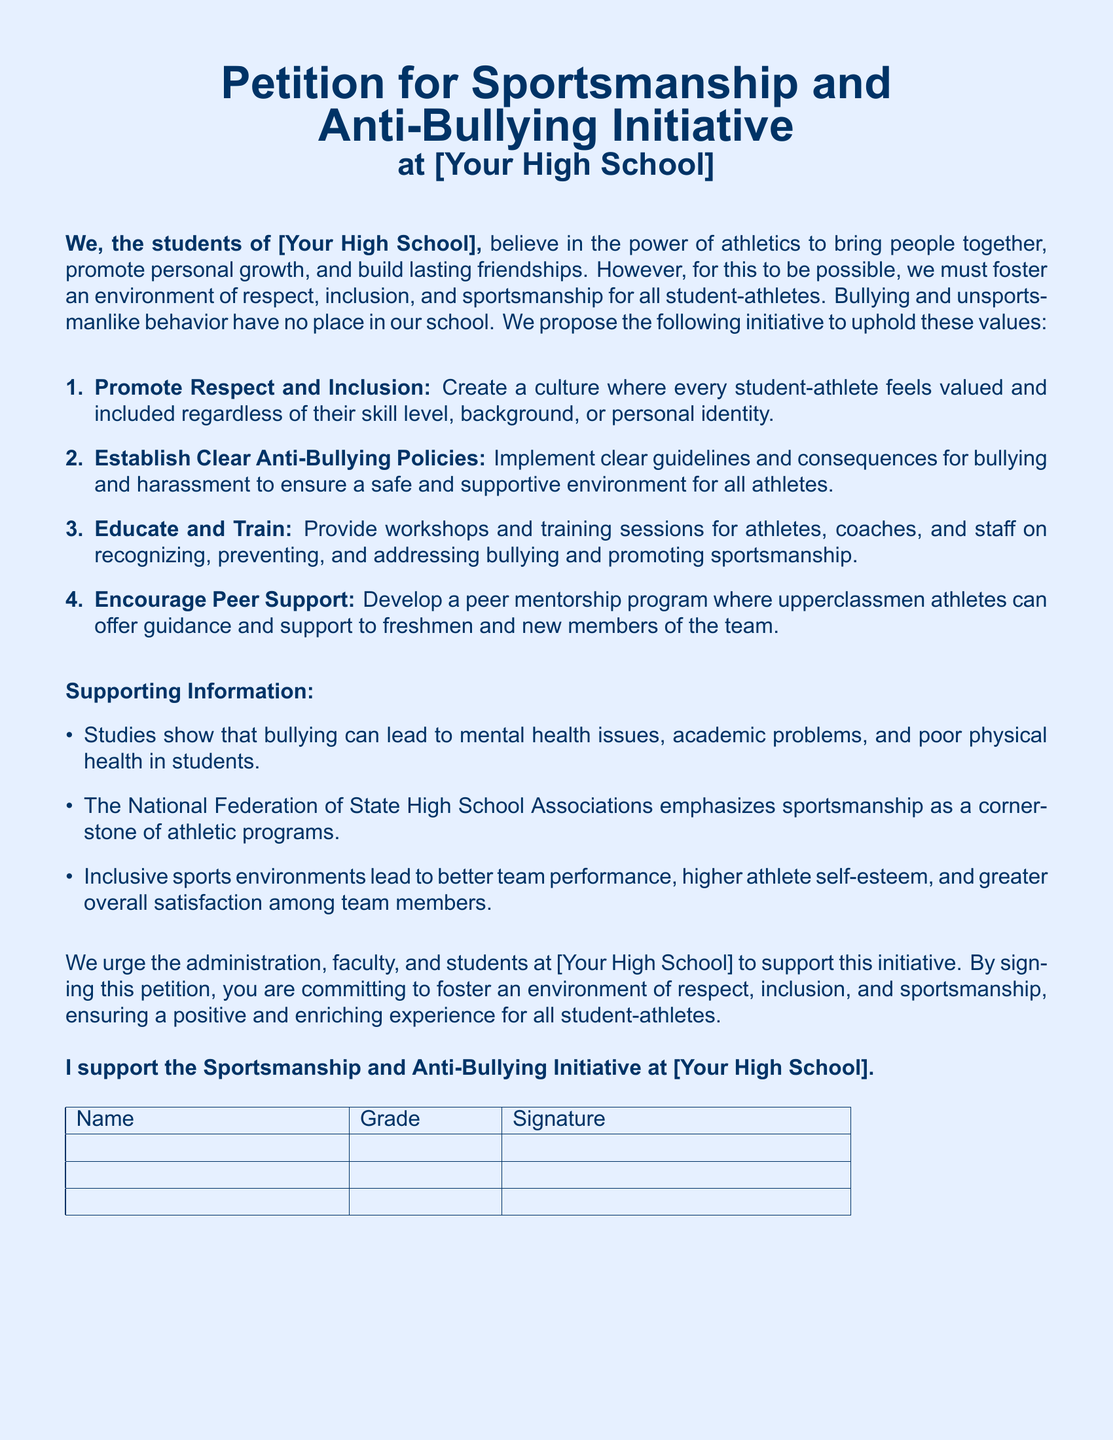What is the title of the petition? The title of the petition is stated at the beginning of the document, which is "Petition for Sportsmanship and Anti-Bullying Initiative."
Answer: Petition for Sportsmanship and Anti-Bullying Initiative What school is the petition addressing? The petition addresses "[Your High School]," which is a placeholder for the actual school name.
Answer: [Your High School] How many points are proposed in the initiative? The document lists four specific points in the initiative, indicating the proposed actions.
Answer: 4 What type of program is suggested for upperclassmen athletes? The initiative includes a suggestion for a peer mentorship program to support newcomers in athletics.
Answer: Peer mentorship program What does the National Federation of State High School Associations emphasize? It emphasizes that sportsmanship is a cornerstone of athletic programs, indicating its importance in sports.
Answer: Sportsmanship What is the main goal of the initiative? The main goal is to foster an environment of respect, inclusion, and sportsmanship among student-athletes.
Answer: Respect, inclusion, and sportsmanship What does the petition ask from the administration and faculty? The petition urges them to support the initiative for creating a positive environment for all student-athletes.
Answer: Support this initiative How is the petition formatted for signatures? The document includes a table to collect names, grades, and signatures of supporters of the initiative.
Answer: Table for signatures 